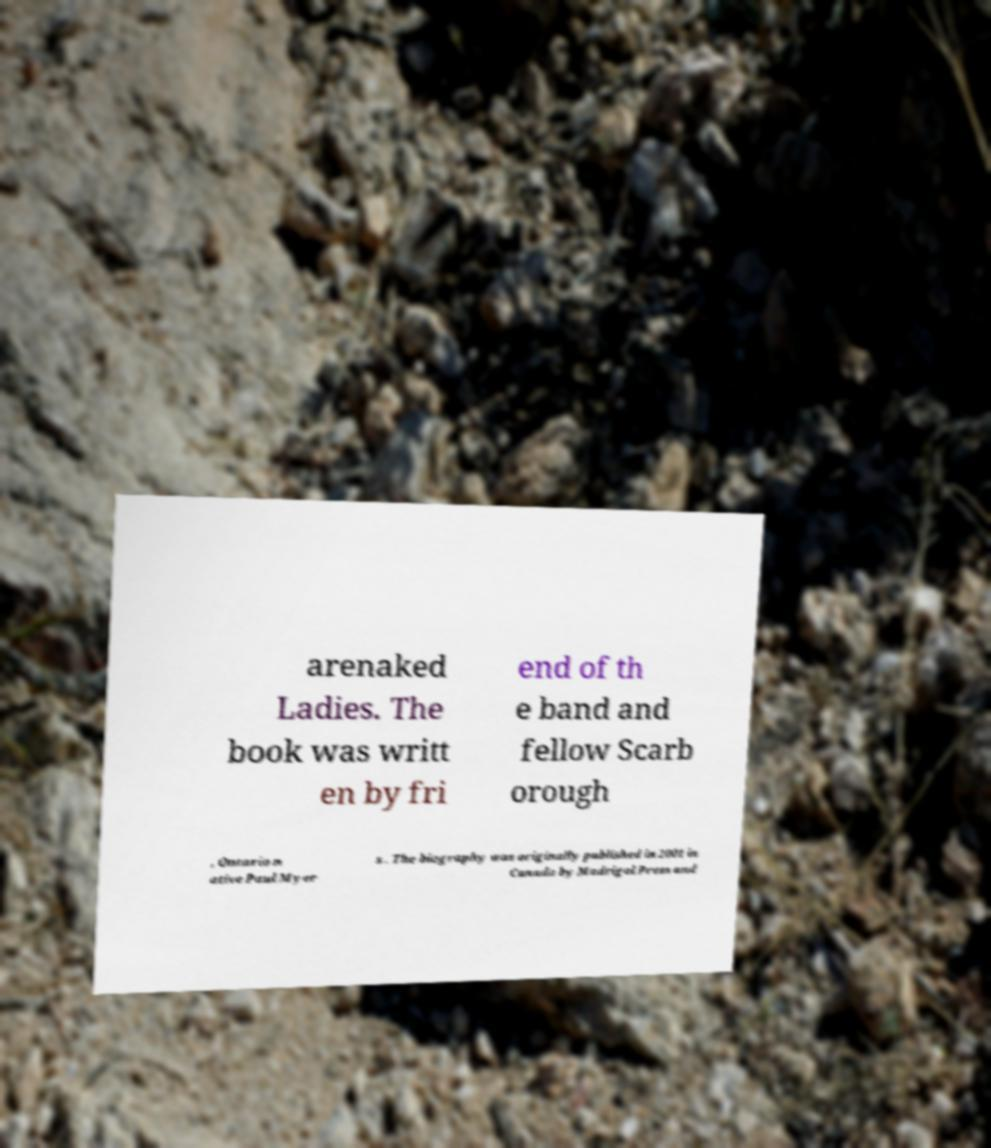Could you extract and type out the text from this image? arenaked Ladies. The book was writt en by fri end of th e band and fellow Scarb orough , Ontario n ative Paul Myer s . The biography was originally published in 2001 in Canada by Madrigal Press and 